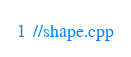<code> <loc_0><loc_0><loc_500><loc_500><_C++_>//shape.cpp</code> 